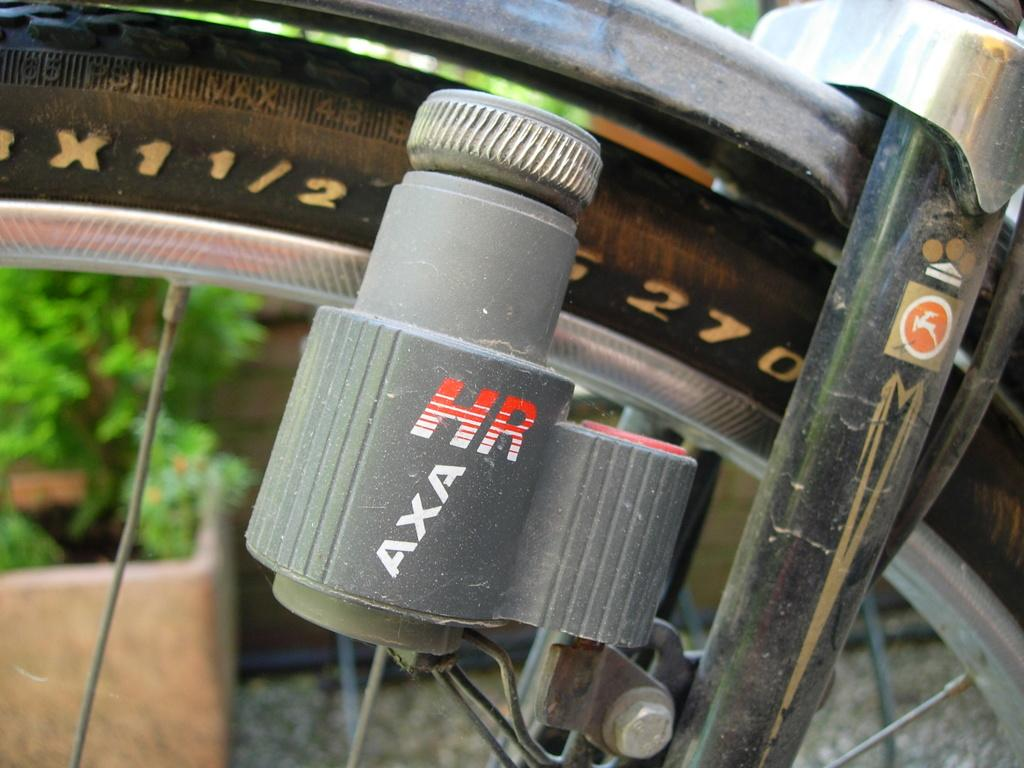What is the main object in the image? There is a bicycle wheel in the image. What other object is related to the bicycle wheel? There is a dynamo in the image. What is the purpose of the dynamo? The dynamo is used to generate electricity, typically for lighting. What can be seen connected to the bicycle wheel and dynamo? There are cables in the image. What can be seen in the background of the image? There are leaves and a pot in the background of the image. What type of face can be seen on the bicycle wheel in the image? There is no face present on the bicycle wheel in the image. 